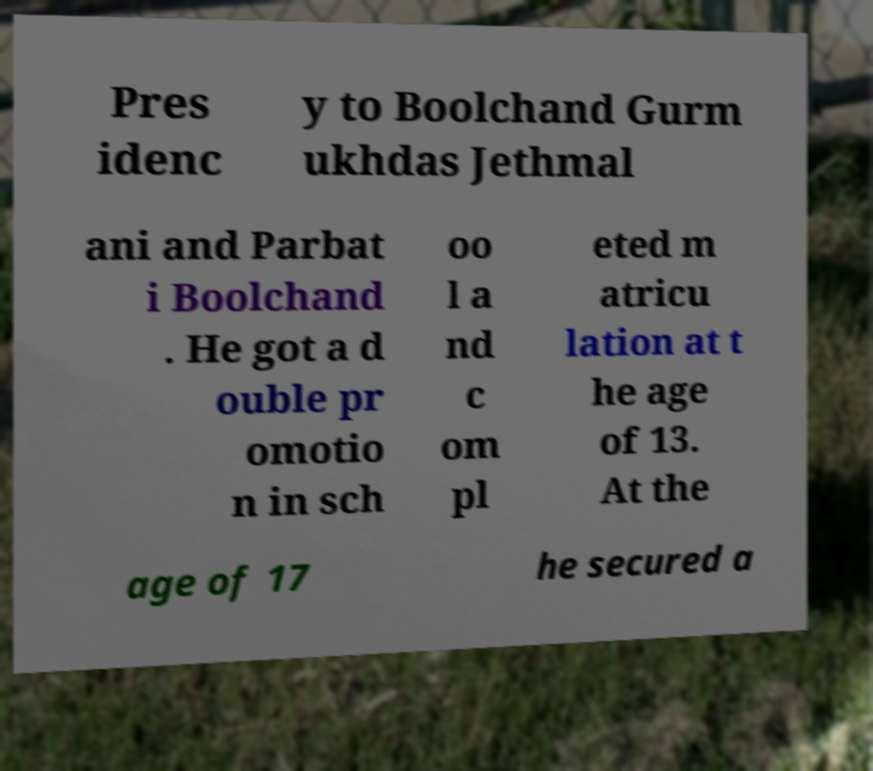Could you assist in decoding the text presented in this image and type it out clearly? Pres idenc y to Boolchand Gurm ukhdas Jethmal ani and Parbat i Boolchand . He got a d ouble pr omotio n in sch oo l a nd c om pl eted m atricu lation at t he age of 13. At the age of 17 he secured a 